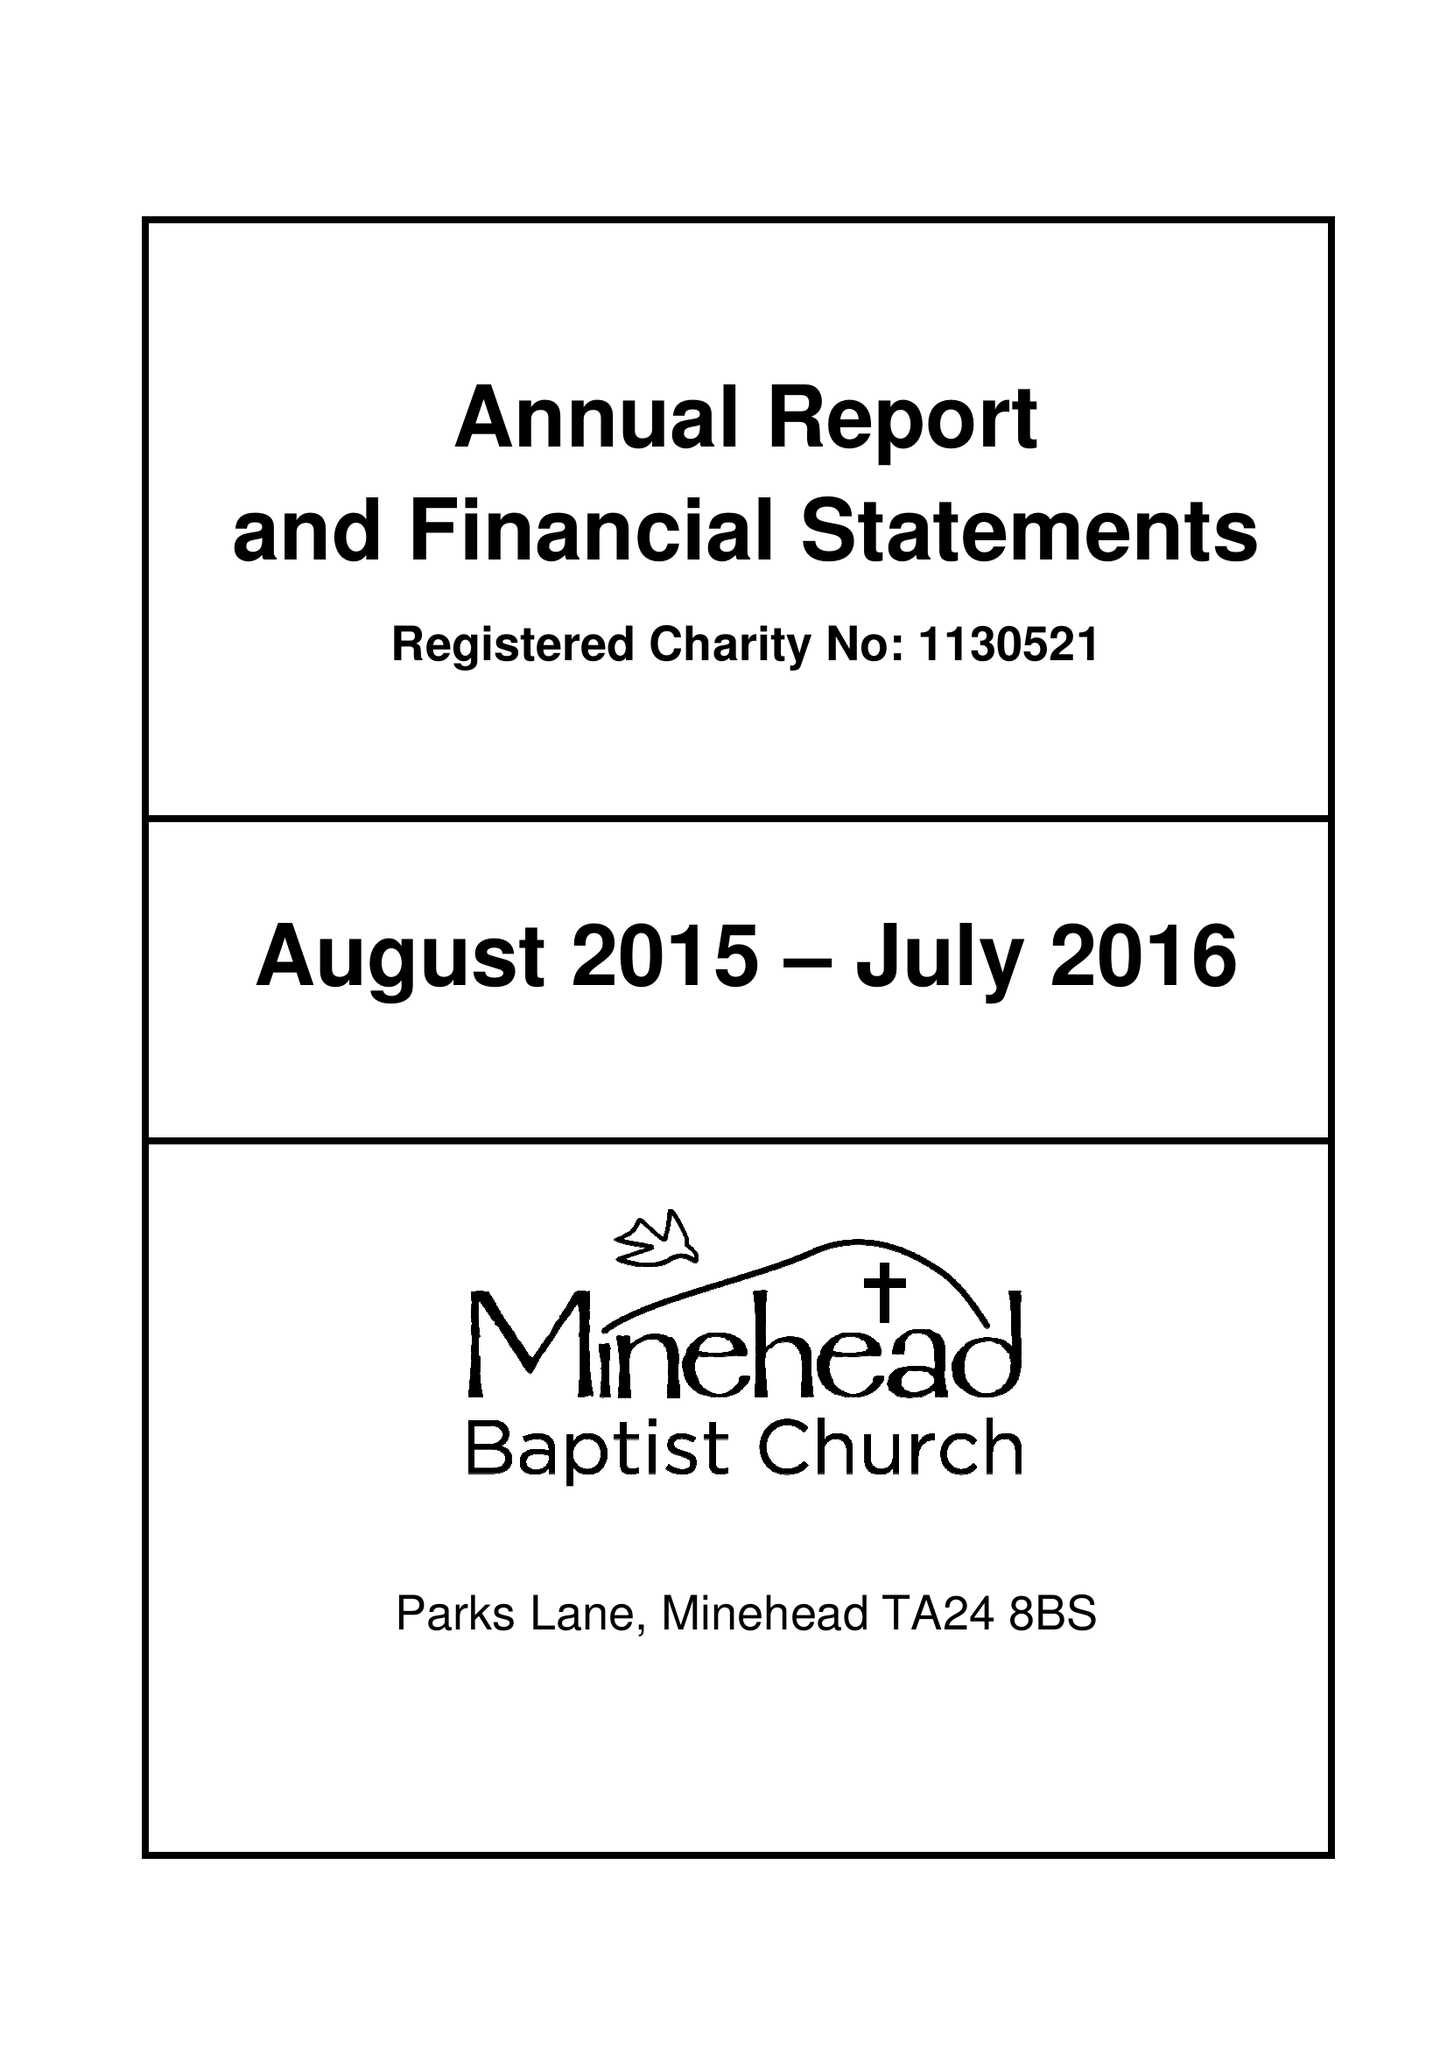What is the value for the spending_annually_in_british_pounds?
Answer the question using a single word or phrase. 254785.00 